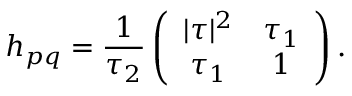Convert formula to latex. <formula><loc_0><loc_0><loc_500><loc_500>h _ { p q } = \frac { 1 } { \tau _ { 2 } } \left ( \begin{array} { c c } { { | \tau | ^ { 2 } } } & { { \tau _ { 1 } } } \\ { { \tau _ { 1 } } } & { 1 } \end{array} \right ) .</formula> 